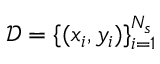Convert formula to latex. <formula><loc_0><loc_0><loc_500><loc_500>\mathcal { D } = \{ ( x _ { i } , y _ { i } ) \} _ { i = 1 } ^ { N _ { s } }</formula> 